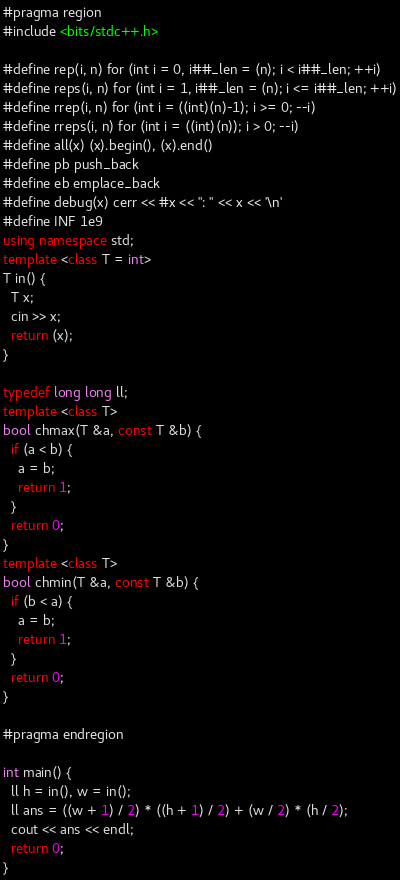Convert code to text. <code><loc_0><loc_0><loc_500><loc_500><_C++_>#pragma region
#include <bits/stdc++.h>

#define rep(i, n) for (int i = 0, i##_len = (n); i < i##_len; ++i)
#define reps(i, n) for (int i = 1, i##_len = (n); i <= i##_len; ++i)
#define rrep(i, n) for (int i = ((int)(n)-1); i >= 0; --i)
#define rreps(i, n) for (int i = ((int)(n)); i > 0; --i)
#define all(x) (x).begin(), (x).end()
#define pb push_back
#define eb emplace_back
#define debug(x) cerr << #x << ": " << x << '\n'
#define INF 1e9
using namespace std;
template <class T = int>
T in() {
  T x;
  cin >> x;
  return (x);
}

typedef long long ll;
template <class T>
bool chmax(T &a, const T &b) {
  if (a < b) {
    a = b;
    return 1;
  }
  return 0;
}
template <class T>
bool chmin(T &a, const T &b) {
  if (b < a) {
    a = b;
    return 1;
  }
  return 0;
}

#pragma endregion

int main() {
  ll h = in(), w = in();
  ll ans = ((w + 1) / 2) * ((h + 1) / 2) + (w / 2) * (h / 2);
  cout << ans << endl;
  return 0;
}
</code> 